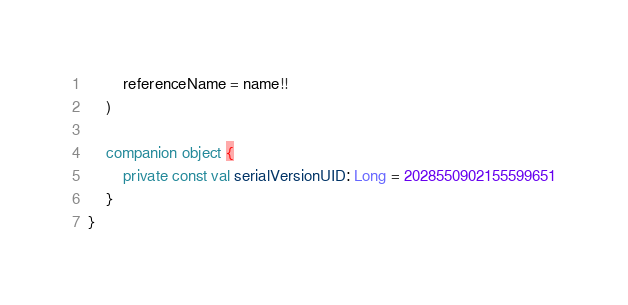Convert code to text. <code><loc_0><loc_0><loc_500><loc_500><_Kotlin_>        referenceName = name!!
    )

    companion object {
        private const val serialVersionUID: Long = 2028550902155599651
    }
}</code> 